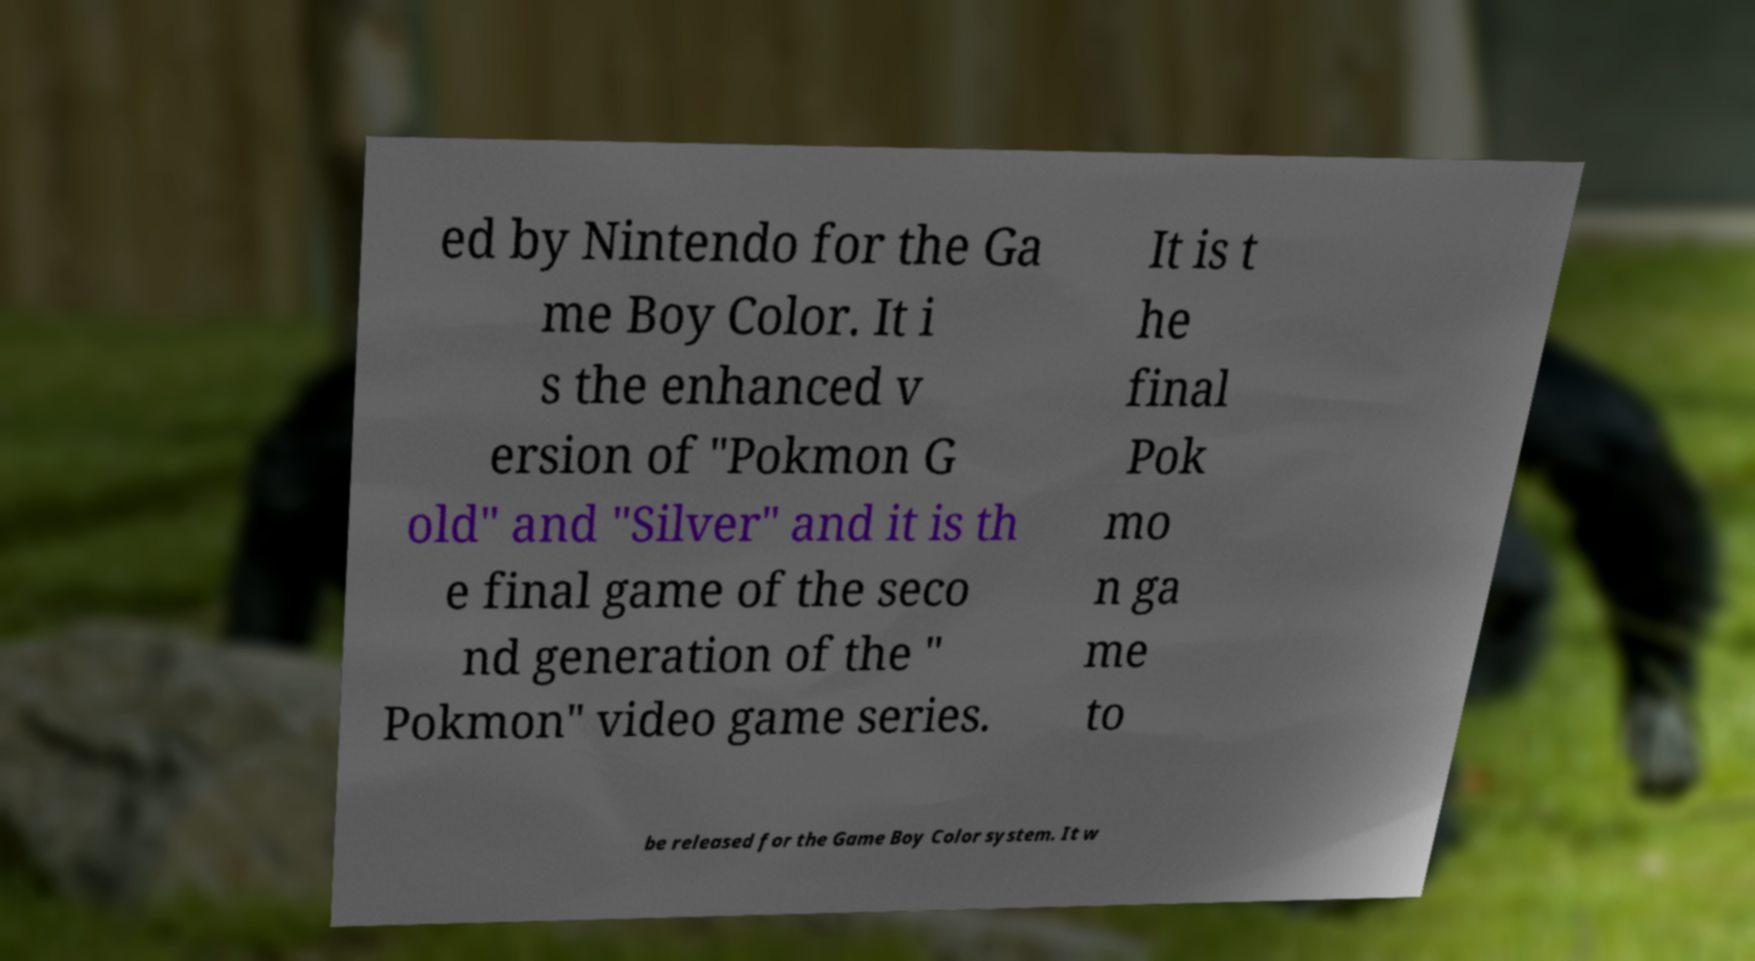For documentation purposes, I need the text within this image transcribed. Could you provide that? ed by Nintendo for the Ga me Boy Color. It i s the enhanced v ersion of "Pokmon G old" and "Silver" and it is th e final game of the seco nd generation of the " Pokmon" video game series. It is t he final Pok mo n ga me to be released for the Game Boy Color system. It w 